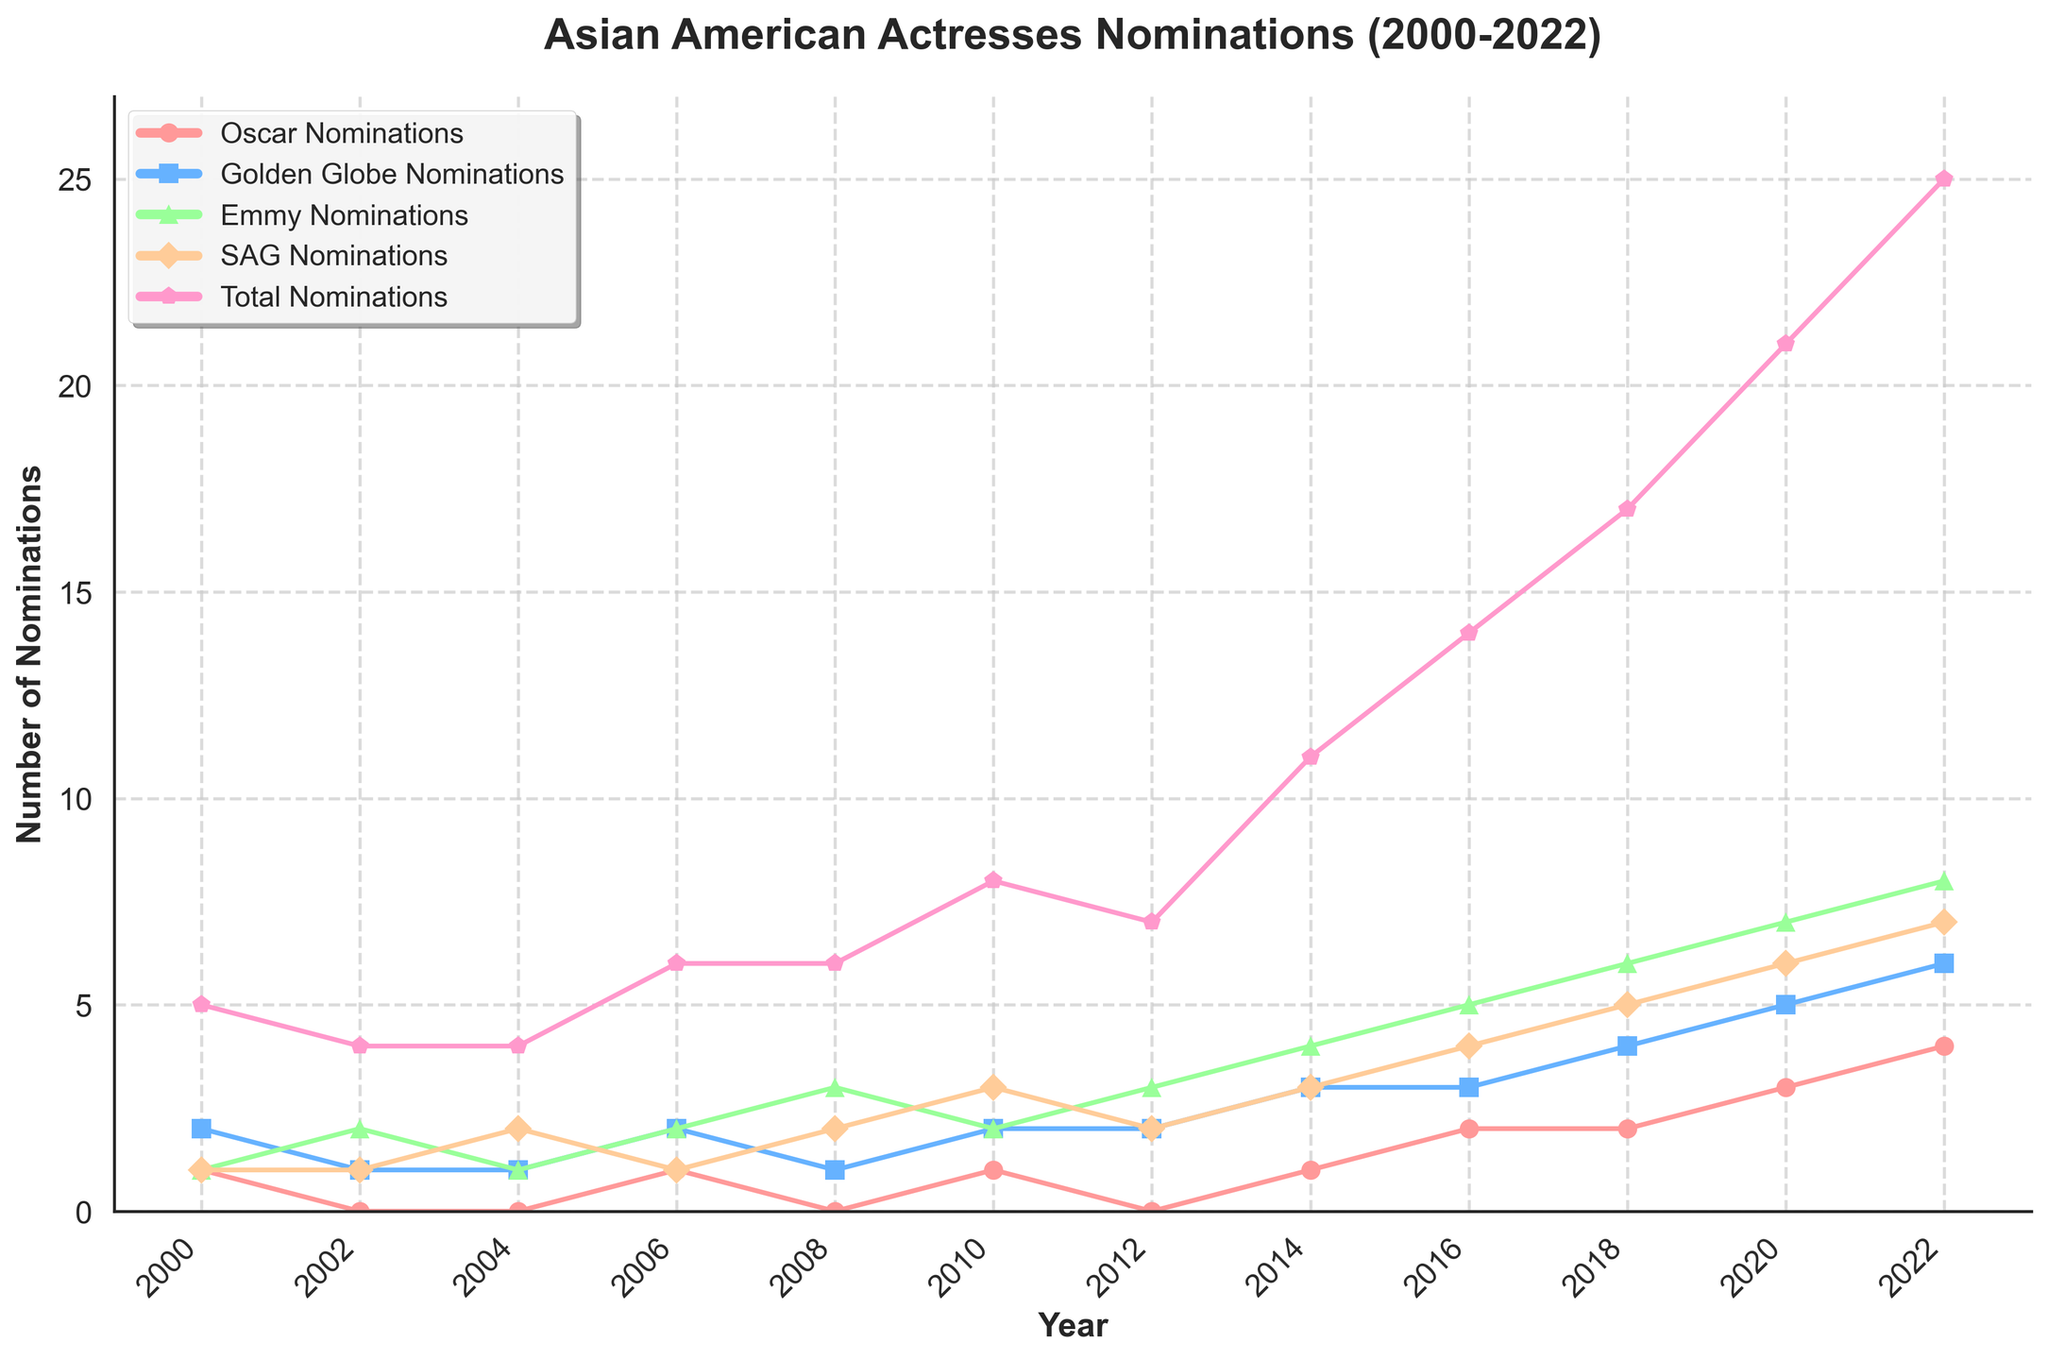How many total nominations were there in 2010? Refer to the plot and look at the "Total Nominations" for the year 2010, which is shown as 8.
Answer: 8 Did the number of Emmy nominations increase or decrease between 2008 and 2010? Look at the "Emmy Nominations" line for the years 2008 (3 nominations) and 2010 (2 nominations). The number decreases from 3 to 2.
Answer: Decrease Which category had the highest nominations in 2022? Refer to 2022 and compare the values for all categories. "Emmy Nominations" shows the highest value, with 8 nominations.
Answer: Emmy Nominations What is the difference between the total nominations in 2006 and 2022? First, note the total nominations: 6 for 2006 and 25 for 2022. Calculate the difference, which is 25 - 6 = 19.
Answer: 19 In which year did the Oscar nominations equal the SAG nominations? Look at both "Oscar Nominations" and "SAG Nominations" and find years where the values match. They match in 2000 and 2006, both showing 1 nomination in each category.
Answer: 2000 and 2006 How many years had more than 5 total nominations? Count the years where the total nominations exceed 5. These years are 2010, 2012, 2014, 2016, 2018, 2020, and 2022, totaling 7 years.
Answer: 7 What’s the average number of Golden Globe nominations from 2000 to 2022? Sum the Golden Globe nominations (2+1+1+2+1+2+2+3+3+4+5+6=32) and divide by the number of years (12), which is 32/12 = 2.67.
Answer: 2.67 Which year saw the steepest increase in total nominations compared to the previous year? Compare the increase in total nominations year over year. The largest increase is between 2020 (21 nominations) and 2022 (25 nominations) with a difference of 4.
Answer: 2022 